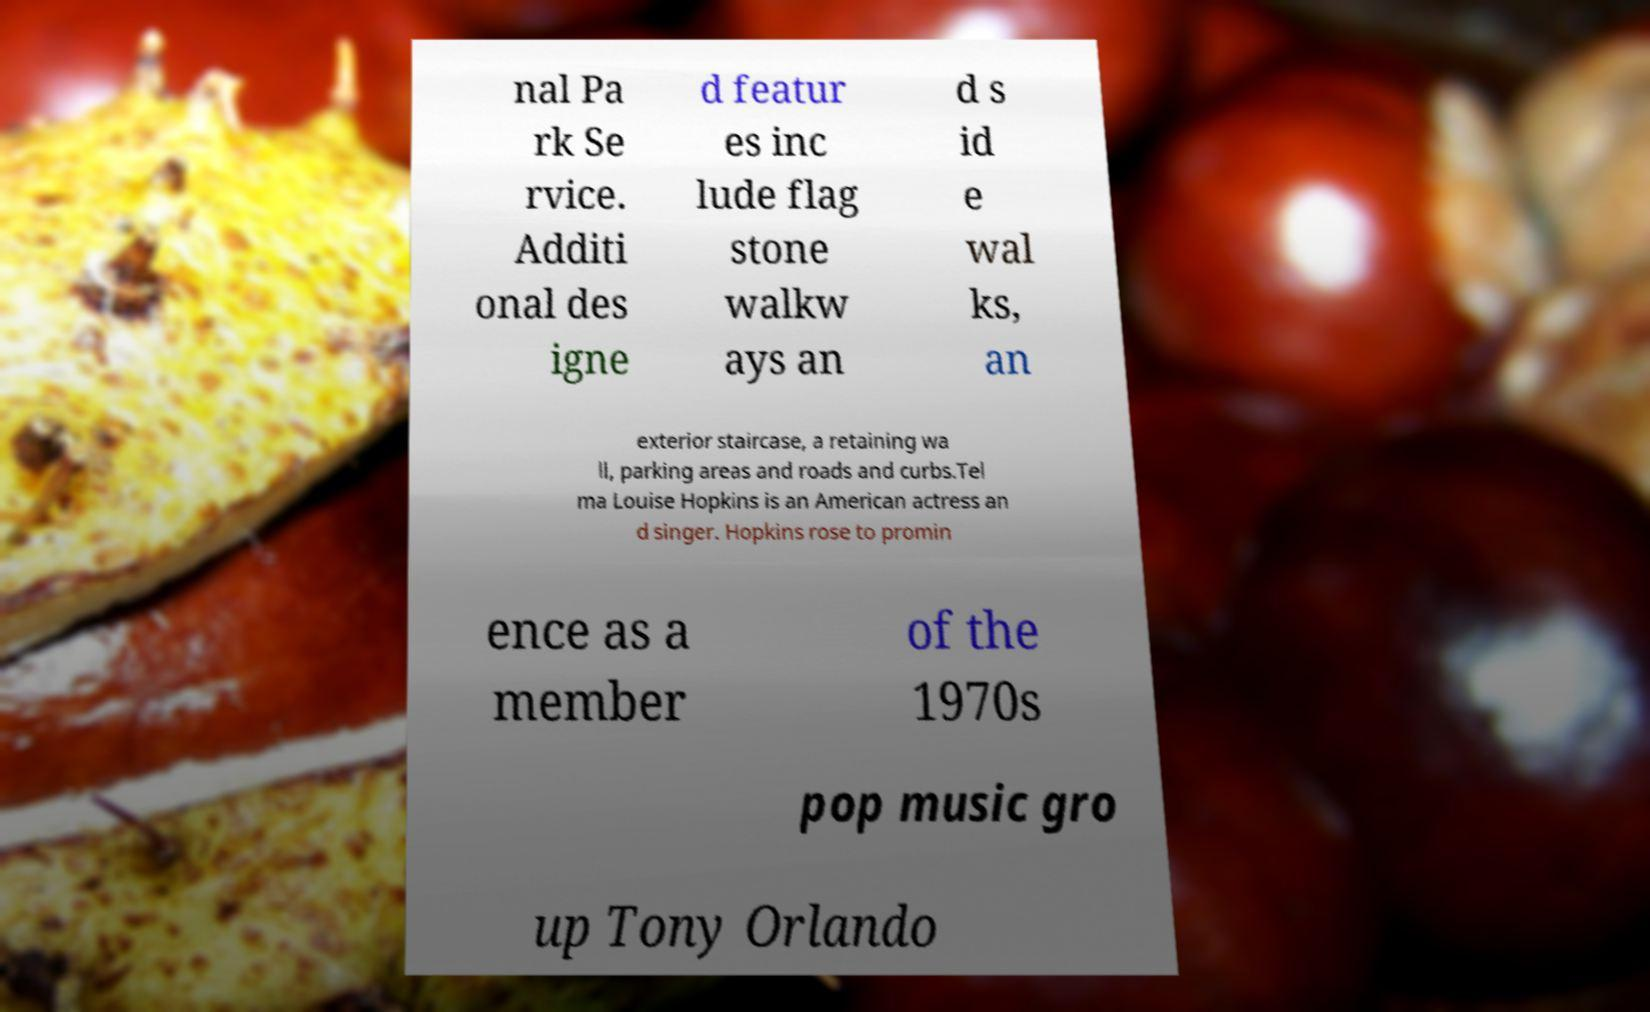I need the written content from this picture converted into text. Can you do that? nal Pa rk Se rvice. Additi onal des igne d featur es inc lude flag stone walkw ays an d s id e wal ks, an exterior staircase, a retaining wa ll, parking areas and roads and curbs.Tel ma Louise Hopkins is an American actress an d singer. Hopkins rose to promin ence as a member of the 1970s pop music gro up Tony Orlando 